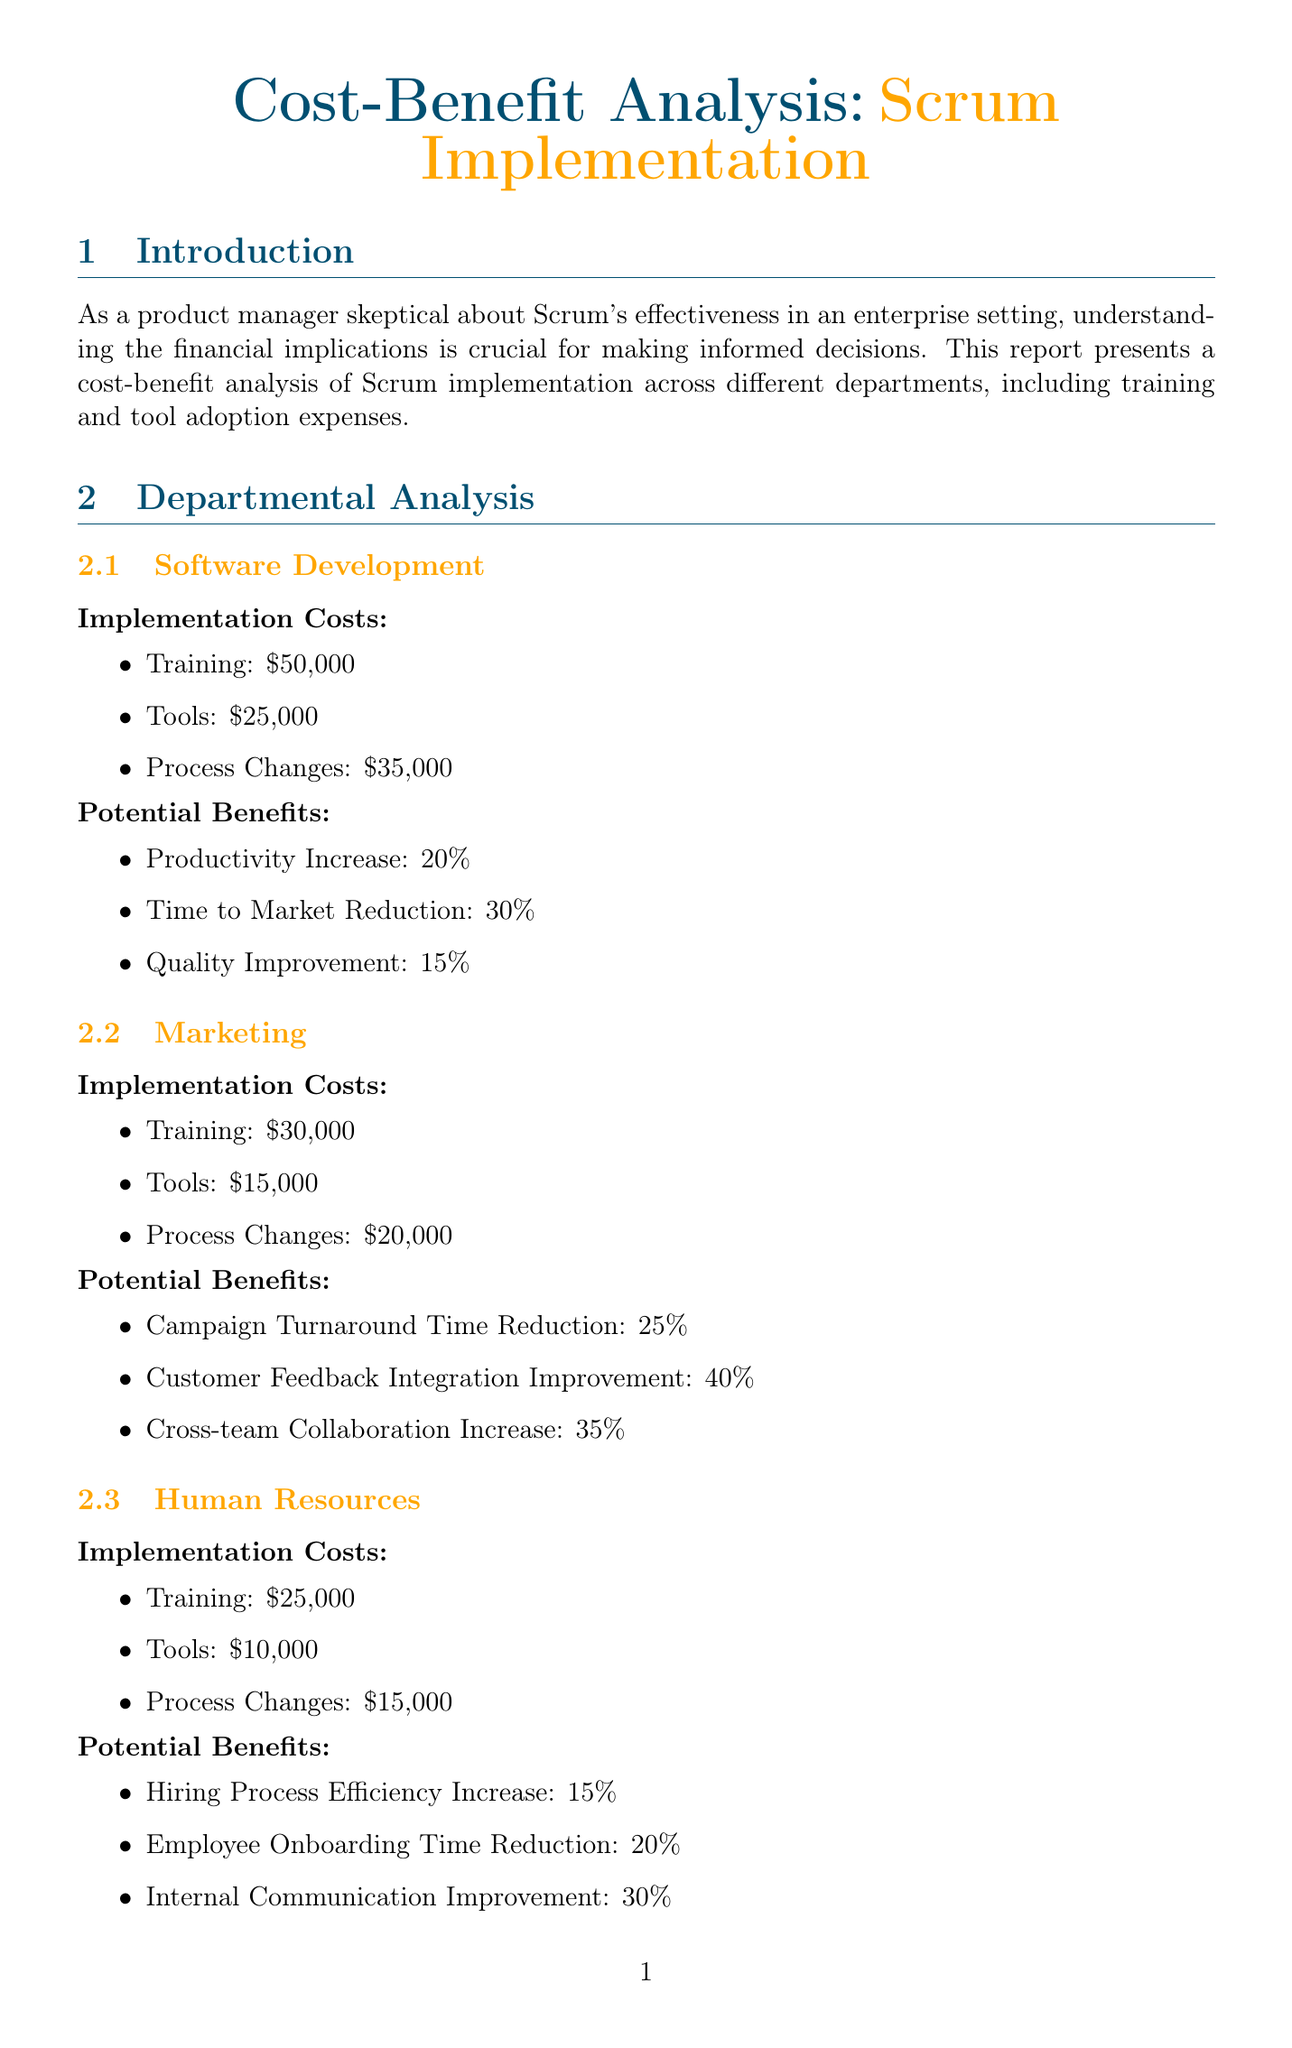what are the total implementation costs for Software Development? The total implementation costs for Software Development are the sum of training, tools, and process changes, which equals $50,000 + $25,000 + $35,000.
Answer: $110,000 what is the potential productivity increase for the Marketing department? The document states the potential benefits for the Marketing department, particularly the productivity increase, which is noted as 25%.
Answer: 25% what training course is offered by Scrum Alliance? The document lists the training providers and their respective courses, indicating that Scrum Alliance offers the Certified ScrumMaster (CSM).
Answer: Certified ScrumMaster (CSM) what is the average breakeven period mentioned for Scrum implementation? The report specifies that the average breakeven period for Scrum implementation is 12-18 months.
Answer: 12-18 months which company experienced a 40% reduction in product development cycle? The document details case studies, stating that General Electric experienced a 40% reduction in product development cycle.
Answer: General Electric what is a key challenge regarding the adoption of Scrum across multiple teams? The document outlines several enterprise challenges, one of which is scaling Scrum across multiple teams and departments.
Answer: Scaling Scrum across multiple teams and departments which tool from Atlassian has an annual cost per user of $150? The document lists Scrum tools, identifying Jira from Atlassian with an annual cost per user of $150.
Answer: Jira what is a pro of the Scaled Agile Framework (SAFe)? The report mentions several pros of Scaled Agile Framework (SAFe), one being that it is designed for enterprise-scale agility.
Answer: Designed for enterprise-scale agility 